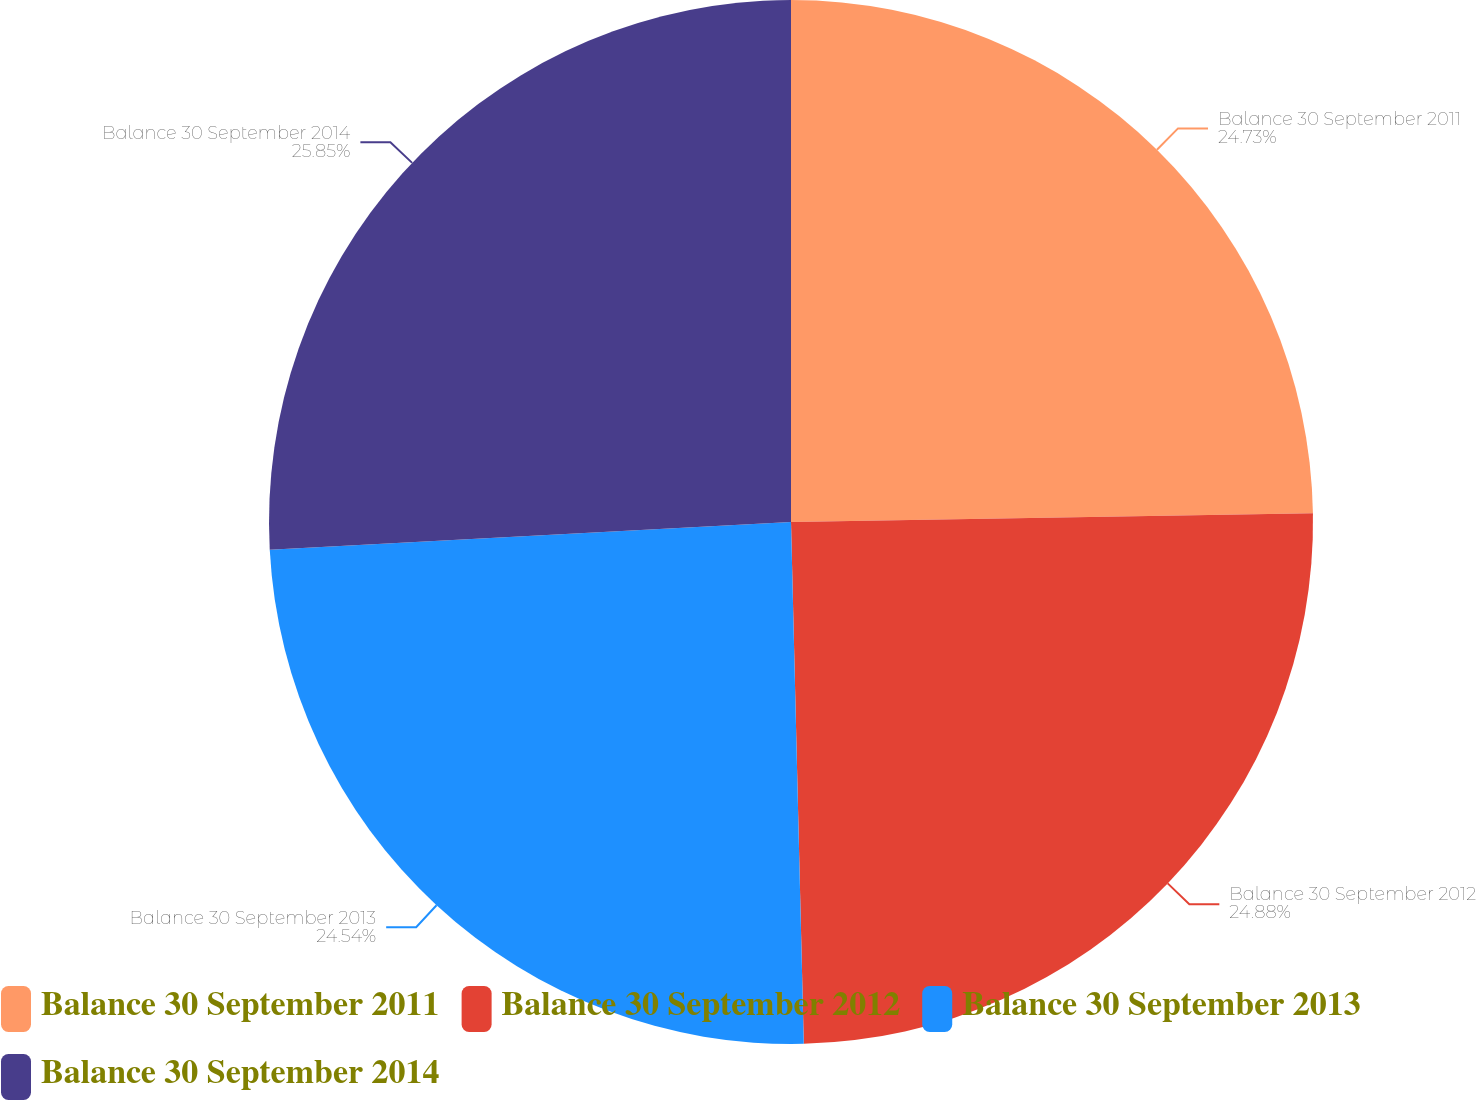<chart> <loc_0><loc_0><loc_500><loc_500><pie_chart><fcel>Balance 30 September 2011<fcel>Balance 30 September 2012<fcel>Balance 30 September 2013<fcel>Balance 30 September 2014<nl><fcel>24.73%<fcel>24.88%<fcel>24.54%<fcel>25.85%<nl></chart> 